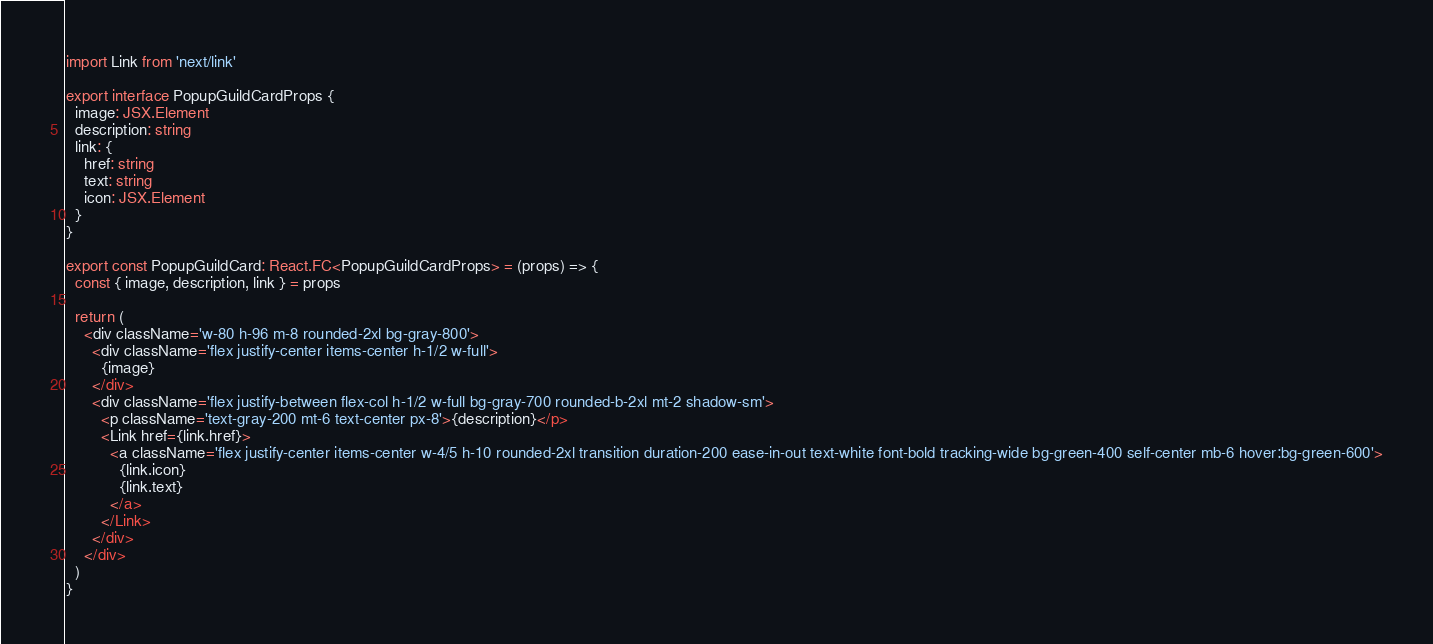<code> <loc_0><loc_0><loc_500><loc_500><_TypeScript_>import Link from 'next/link'

export interface PopupGuildCardProps {
  image: JSX.Element
  description: string
  link: {
    href: string
    text: string
    icon: JSX.Element
  }
}

export const PopupGuildCard: React.FC<PopupGuildCardProps> = (props) => {
  const { image, description, link } = props

  return (
    <div className='w-80 h-96 m-8 rounded-2xl bg-gray-800'>
      <div className='flex justify-center items-center h-1/2 w-full'>
        {image}
      </div>
      <div className='flex justify-between flex-col h-1/2 w-full bg-gray-700 rounded-b-2xl mt-2 shadow-sm'>
        <p className='text-gray-200 mt-6 text-center px-8'>{description}</p>
        <Link href={link.href}>
          <a className='flex justify-center items-center w-4/5 h-10 rounded-2xl transition duration-200 ease-in-out text-white font-bold tracking-wide bg-green-400 self-center mb-6 hover:bg-green-600'>
            {link.icon}
            {link.text}
          </a>
        </Link>
      </div>
    </div>
  )
}
</code> 